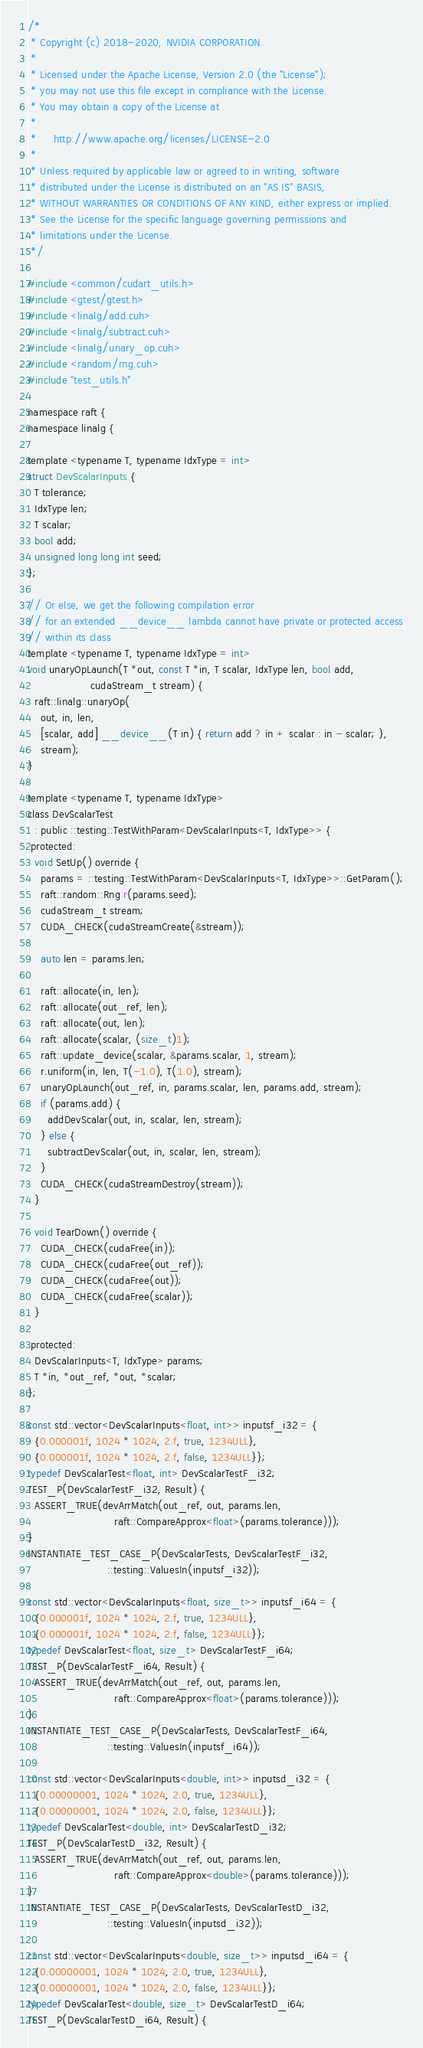Convert code to text. <code><loc_0><loc_0><loc_500><loc_500><_Cuda_>/*
 * Copyright (c) 2018-2020, NVIDIA CORPORATION.
 *
 * Licensed under the Apache License, Version 2.0 (the "License");
 * you may not use this file except in compliance with the License.
 * You may obtain a copy of the License at
 *
 *     http://www.apache.org/licenses/LICENSE-2.0
 *
 * Unless required by applicable law or agreed to in writing, software
 * distributed under the License is distributed on an "AS IS" BASIS,
 * WITHOUT WARRANTIES OR CONDITIONS OF ANY KIND, either express or implied.
 * See the License for the specific language governing permissions and
 * limitations under the License.
 */

#include <common/cudart_utils.h>
#include <gtest/gtest.h>
#include <linalg/add.cuh>
#include <linalg/subtract.cuh>
#include <linalg/unary_op.cuh>
#include <random/rng.cuh>
#include "test_utils.h"

namespace raft {
namespace linalg {

template <typename T, typename IdxType = int>
struct DevScalarInputs {
  T tolerance;
  IdxType len;
  T scalar;
  bool add;
  unsigned long long int seed;
};

// Or else, we get the following compilation error
// for an extended __device__ lambda cannot have private or protected access
// within its class
template <typename T, typename IdxType = int>
void unaryOpLaunch(T *out, const T *in, T scalar, IdxType len, bool add,
                   cudaStream_t stream) {
  raft::linalg::unaryOp(
    out, in, len,
    [scalar, add] __device__(T in) { return add ? in + scalar : in - scalar; },
    stream);
}

template <typename T, typename IdxType>
class DevScalarTest
  : public ::testing::TestWithParam<DevScalarInputs<T, IdxType>> {
 protected:
  void SetUp() override {
    params = ::testing::TestWithParam<DevScalarInputs<T, IdxType>>::GetParam();
    raft::random::Rng r(params.seed);
    cudaStream_t stream;
    CUDA_CHECK(cudaStreamCreate(&stream));

    auto len = params.len;

    raft::allocate(in, len);
    raft::allocate(out_ref, len);
    raft::allocate(out, len);
    raft::allocate(scalar, (size_t)1);
    raft::update_device(scalar, &params.scalar, 1, stream);
    r.uniform(in, len, T(-1.0), T(1.0), stream);
    unaryOpLaunch(out_ref, in, params.scalar, len, params.add, stream);
    if (params.add) {
      addDevScalar(out, in, scalar, len, stream);
    } else {
      subtractDevScalar(out, in, scalar, len, stream);
    }
    CUDA_CHECK(cudaStreamDestroy(stream));
  }

  void TearDown() override {
    CUDA_CHECK(cudaFree(in));
    CUDA_CHECK(cudaFree(out_ref));
    CUDA_CHECK(cudaFree(out));
    CUDA_CHECK(cudaFree(scalar));
  }

 protected:
  DevScalarInputs<T, IdxType> params;
  T *in, *out_ref, *out, *scalar;
};

const std::vector<DevScalarInputs<float, int>> inputsf_i32 = {
  {0.000001f, 1024 * 1024, 2.f, true, 1234ULL},
  {0.000001f, 1024 * 1024, 2.f, false, 1234ULL}};
typedef DevScalarTest<float, int> DevScalarTestF_i32;
TEST_P(DevScalarTestF_i32, Result) {
  ASSERT_TRUE(devArrMatch(out_ref, out, params.len,
                          raft::CompareApprox<float>(params.tolerance)));
}
INSTANTIATE_TEST_CASE_P(DevScalarTests, DevScalarTestF_i32,
                        ::testing::ValuesIn(inputsf_i32));

const std::vector<DevScalarInputs<float, size_t>> inputsf_i64 = {
  {0.000001f, 1024 * 1024, 2.f, true, 1234ULL},
  {0.000001f, 1024 * 1024, 2.f, false, 1234ULL}};
typedef DevScalarTest<float, size_t> DevScalarTestF_i64;
TEST_P(DevScalarTestF_i64, Result) {
  ASSERT_TRUE(devArrMatch(out_ref, out, params.len,
                          raft::CompareApprox<float>(params.tolerance)));
}
INSTANTIATE_TEST_CASE_P(DevScalarTests, DevScalarTestF_i64,
                        ::testing::ValuesIn(inputsf_i64));

const std::vector<DevScalarInputs<double, int>> inputsd_i32 = {
  {0.00000001, 1024 * 1024, 2.0, true, 1234ULL},
  {0.00000001, 1024 * 1024, 2.0, false, 1234ULL}};
typedef DevScalarTest<double, int> DevScalarTestD_i32;
TEST_P(DevScalarTestD_i32, Result) {
  ASSERT_TRUE(devArrMatch(out_ref, out, params.len,
                          raft::CompareApprox<double>(params.tolerance)));
}
INSTANTIATE_TEST_CASE_P(DevScalarTests, DevScalarTestD_i32,
                        ::testing::ValuesIn(inputsd_i32));

const std::vector<DevScalarInputs<double, size_t>> inputsd_i64 = {
  {0.00000001, 1024 * 1024, 2.0, true, 1234ULL},
  {0.00000001, 1024 * 1024, 2.0, false, 1234ULL}};
typedef DevScalarTest<double, size_t> DevScalarTestD_i64;
TEST_P(DevScalarTestD_i64, Result) {</code> 